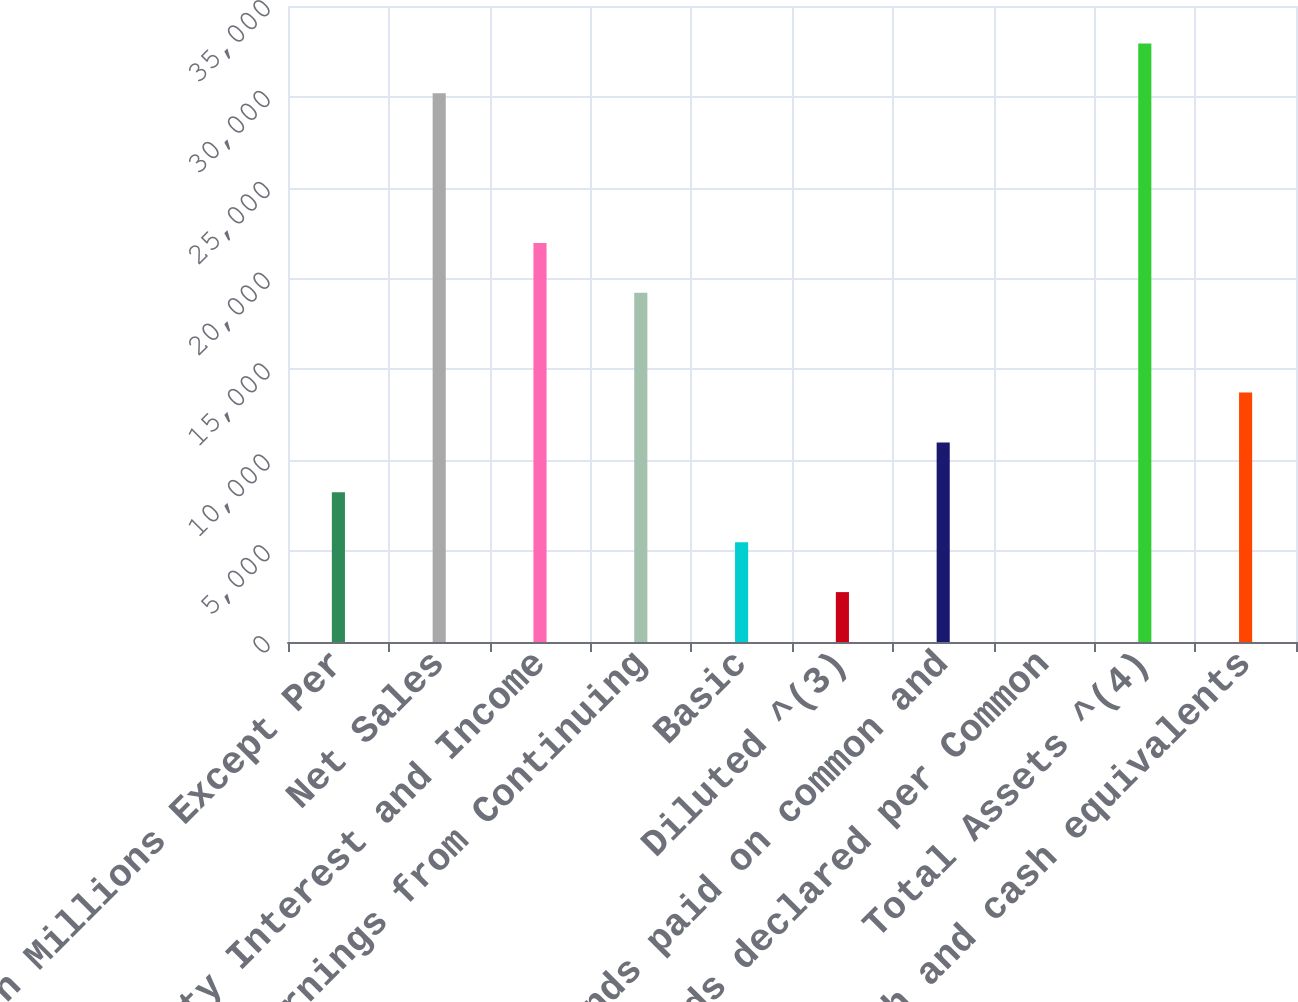Convert chart to OTSL. <chart><loc_0><loc_0><loc_500><loc_500><bar_chart><fcel>Amounts in Millions Except Per<fcel>Net Sales<fcel>Minority Interest and Income<fcel>Earnings from Continuing<fcel>Basic<fcel>Diluted ^(3)<fcel>Dividends paid on common and<fcel>Dividends declared per Common<fcel>Total Assets ^(4)<fcel>Cash and cash equivalents<nl><fcel>8235.19<fcel>30192.7<fcel>21958.6<fcel>19214<fcel>5490.5<fcel>2745.81<fcel>10979.9<fcel>1.12<fcel>32937.4<fcel>13724.6<nl></chart> 